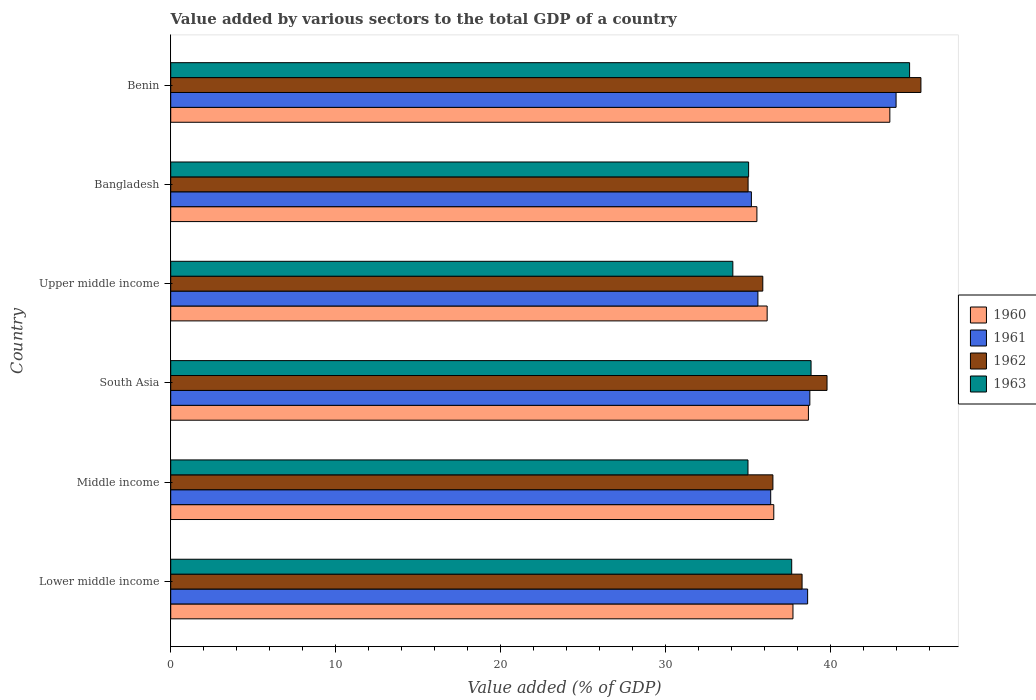How many groups of bars are there?
Keep it short and to the point. 6. How many bars are there on the 6th tick from the top?
Offer a terse response. 4. What is the value added by various sectors to the total GDP in 1960 in South Asia?
Ensure brevity in your answer.  38.68. Across all countries, what is the maximum value added by various sectors to the total GDP in 1963?
Make the answer very short. 44.81. Across all countries, what is the minimum value added by various sectors to the total GDP in 1960?
Give a very brief answer. 35.55. In which country was the value added by various sectors to the total GDP in 1961 maximum?
Make the answer very short. Benin. In which country was the value added by various sectors to the total GDP in 1960 minimum?
Provide a short and direct response. Bangladesh. What is the total value added by various sectors to the total GDP in 1963 in the graph?
Ensure brevity in your answer.  225.46. What is the difference between the value added by various sectors to the total GDP in 1961 in Benin and that in Lower middle income?
Make the answer very short. 5.36. What is the difference between the value added by various sectors to the total GDP in 1960 in Middle income and the value added by various sectors to the total GDP in 1963 in Benin?
Make the answer very short. -8.24. What is the average value added by various sectors to the total GDP in 1962 per country?
Offer a terse response. 38.51. What is the difference between the value added by various sectors to the total GDP in 1961 and value added by various sectors to the total GDP in 1963 in Benin?
Your answer should be very brief. -0.82. In how many countries, is the value added by various sectors to the total GDP in 1963 greater than 24 %?
Your answer should be very brief. 6. What is the ratio of the value added by various sectors to the total GDP in 1961 in Benin to that in Lower middle income?
Your answer should be compact. 1.14. What is the difference between the highest and the second highest value added by various sectors to the total GDP in 1962?
Your answer should be very brief. 5.69. What is the difference between the highest and the lowest value added by various sectors to the total GDP in 1962?
Offer a very short reply. 10.48. Is it the case that in every country, the sum of the value added by various sectors to the total GDP in 1960 and value added by various sectors to the total GDP in 1963 is greater than the sum of value added by various sectors to the total GDP in 1962 and value added by various sectors to the total GDP in 1961?
Ensure brevity in your answer.  No. What does the 3rd bar from the top in Benin represents?
Make the answer very short. 1961. Is it the case that in every country, the sum of the value added by various sectors to the total GDP in 1963 and value added by various sectors to the total GDP in 1960 is greater than the value added by various sectors to the total GDP in 1961?
Your answer should be very brief. Yes. How many bars are there?
Provide a short and direct response. 24. Are all the bars in the graph horizontal?
Ensure brevity in your answer.  Yes. How many countries are there in the graph?
Give a very brief answer. 6. Does the graph contain any zero values?
Your response must be concise. No. How are the legend labels stacked?
Give a very brief answer. Vertical. What is the title of the graph?
Make the answer very short. Value added by various sectors to the total GDP of a country. Does "2014" appear as one of the legend labels in the graph?
Your answer should be compact. No. What is the label or title of the X-axis?
Keep it short and to the point. Value added (% of GDP). What is the label or title of the Y-axis?
Your answer should be compact. Country. What is the Value added (% of GDP) of 1960 in Lower middle income?
Offer a very short reply. 37.74. What is the Value added (% of GDP) in 1961 in Lower middle income?
Your answer should be compact. 38.63. What is the Value added (% of GDP) in 1962 in Lower middle income?
Ensure brevity in your answer.  38.29. What is the Value added (% of GDP) in 1963 in Lower middle income?
Provide a short and direct response. 37.66. What is the Value added (% of GDP) in 1960 in Middle income?
Provide a succinct answer. 36.58. What is the Value added (% of GDP) in 1961 in Middle income?
Offer a very short reply. 36.39. What is the Value added (% of GDP) of 1962 in Middle income?
Keep it short and to the point. 36.52. What is the Value added (% of GDP) of 1963 in Middle income?
Your answer should be very brief. 35.01. What is the Value added (% of GDP) of 1960 in South Asia?
Your answer should be compact. 38.68. What is the Value added (% of GDP) of 1961 in South Asia?
Offer a very short reply. 38.76. What is the Value added (% of GDP) of 1962 in South Asia?
Your response must be concise. 39.81. What is the Value added (% of GDP) of 1963 in South Asia?
Keep it short and to the point. 38.84. What is the Value added (% of GDP) of 1960 in Upper middle income?
Your answer should be compact. 36.17. What is the Value added (% of GDP) of 1961 in Upper middle income?
Ensure brevity in your answer.  35.61. What is the Value added (% of GDP) of 1962 in Upper middle income?
Provide a short and direct response. 35.91. What is the Value added (% of GDP) of 1963 in Upper middle income?
Keep it short and to the point. 34.09. What is the Value added (% of GDP) in 1960 in Bangladesh?
Provide a short and direct response. 35.55. What is the Value added (% of GDP) of 1961 in Bangladesh?
Provide a short and direct response. 35.22. What is the Value added (% of GDP) in 1962 in Bangladesh?
Give a very brief answer. 35.02. What is the Value added (% of GDP) of 1963 in Bangladesh?
Provide a short and direct response. 35.05. What is the Value added (% of GDP) in 1960 in Benin?
Your answer should be compact. 43.62. What is the Value added (% of GDP) of 1961 in Benin?
Your answer should be compact. 43.99. What is the Value added (% of GDP) of 1962 in Benin?
Your answer should be compact. 45.5. What is the Value added (% of GDP) in 1963 in Benin?
Your answer should be very brief. 44.81. Across all countries, what is the maximum Value added (% of GDP) of 1960?
Your response must be concise. 43.62. Across all countries, what is the maximum Value added (% of GDP) in 1961?
Make the answer very short. 43.99. Across all countries, what is the maximum Value added (% of GDP) in 1962?
Ensure brevity in your answer.  45.5. Across all countries, what is the maximum Value added (% of GDP) of 1963?
Offer a very short reply. 44.81. Across all countries, what is the minimum Value added (% of GDP) of 1960?
Provide a succinct answer. 35.55. Across all countries, what is the minimum Value added (% of GDP) of 1961?
Offer a very short reply. 35.22. Across all countries, what is the minimum Value added (% of GDP) in 1962?
Make the answer very short. 35.02. Across all countries, what is the minimum Value added (% of GDP) of 1963?
Provide a short and direct response. 34.09. What is the total Value added (% of GDP) in 1960 in the graph?
Provide a short and direct response. 228.33. What is the total Value added (% of GDP) in 1961 in the graph?
Provide a short and direct response. 228.6. What is the total Value added (% of GDP) in 1962 in the graph?
Keep it short and to the point. 231.05. What is the total Value added (% of GDP) of 1963 in the graph?
Keep it short and to the point. 225.46. What is the difference between the Value added (% of GDP) of 1960 in Lower middle income and that in Middle income?
Give a very brief answer. 1.16. What is the difference between the Value added (% of GDP) in 1961 in Lower middle income and that in Middle income?
Keep it short and to the point. 2.24. What is the difference between the Value added (% of GDP) of 1962 in Lower middle income and that in Middle income?
Your answer should be very brief. 1.77. What is the difference between the Value added (% of GDP) of 1963 in Lower middle income and that in Middle income?
Provide a short and direct response. 2.65. What is the difference between the Value added (% of GDP) of 1960 in Lower middle income and that in South Asia?
Keep it short and to the point. -0.94. What is the difference between the Value added (% of GDP) in 1961 in Lower middle income and that in South Asia?
Offer a terse response. -0.13. What is the difference between the Value added (% of GDP) of 1962 in Lower middle income and that in South Asia?
Your answer should be very brief. -1.51. What is the difference between the Value added (% of GDP) in 1963 in Lower middle income and that in South Asia?
Give a very brief answer. -1.17. What is the difference between the Value added (% of GDP) of 1960 in Lower middle income and that in Upper middle income?
Ensure brevity in your answer.  1.57. What is the difference between the Value added (% of GDP) in 1961 in Lower middle income and that in Upper middle income?
Offer a very short reply. 3.02. What is the difference between the Value added (% of GDP) of 1962 in Lower middle income and that in Upper middle income?
Provide a succinct answer. 2.38. What is the difference between the Value added (% of GDP) in 1963 in Lower middle income and that in Upper middle income?
Your answer should be very brief. 3.57. What is the difference between the Value added (% of GDP) in 1960 in Lower middle income and that in Bangladesh?
Offer a very short reply. 2.19. What is the difference between the Value added (% of GDP) of 1961 in Lower middle income and that in Bangladesh?
Offer a very short reply. 3.41. What is the difference between the Value added (% of GDP) of 1962 in Lower middle income and that in Bangladesh?
Give a very brief answer. 3.27. What is the difference between the Value added (% of GDP) of 1963 in Lower middle income and that in Bangladesh?
Keep it short and to the point. 2.61. What is the difference between the Value added (% of GDP) in 1960 in Lower middle income and that in Benin?
Provide a short and direct response. -5.88. What is the difference between the Value added (% of GDP) in 1961 in Lower middle income and that in Benin?
Keep it short and to the point. -5.36. What is the difference between the Value added (% of GDP) in 1962 in Lower middle income and that in Benin?
Give a very brief answer. -7.21. What is the difference between the Value added (% of GDP) in 1963 in Lower middle income and that in Benin?
Your answer should be very brief. -7.15. What is the difference between the Value added (% of GDP) in 1960 in Middle income and that in South Asia?
Give a very brief answer. -2.1. What is the difference between the Value added (% of GDP) of 1961 in Middle income and that in South Asia?
Give a very brief answer. -2.37. What is the difference between the Value added (% of GDP) of 1962 in Middle income and that in South Asia?
Your response must be concise. -3.28. What is the difference between the Value added (% of GDP) in 1963 in Middle income and that in South Asia?
Offer a very short reply. -3.83. What is the difference between the Value added (% of GDP) of 1960 in Middle income and that in Upper middle income?
Provide a short and direct response. 0.4. What is the difference between the Value added (% of GDP) in 1961 in Middle income and that in Upper middle income?
Make the answer very short. 0.78. What is the difference between the Value added (% of GDP) of 1962 in Middle income and that in Upper middle income?
Your answer should be compact. 0.61. What is the difference between the Value added (% of GDP) of 1963 in Middle income and that in Upper middle income?
Provide a short and direct response. 0.92. What is the difference between the Value added (% of GDP) in 1960 in Middle income and that in Bangladesh?
Make the answer very short. 1.02. What is the difference between the Value added (% of GDP) in 1961 in Middle income and that in Bangladesh?
Your response must be concise. 1.17. What is the difference between the Value added (% of GDP) of 1962 in Middle income and that in Bangladesh?
Give a very brief answer. 1.5. What is the difference between the Value added (% of GDP) of 1963 in Middle income and that in Bangladesh?
Make the answer very short. -0.04. What is the difference between the Value added (% of GDP) of 1960 in Middle income and that in Benin?
Your answer should be very brief. -7.04. What is the difference between the Value added (% of GDP) in 1961 in Middle income and that in Benin?
Provide a short and direct response. -7.6. What is the difference between the Value added (% of GDP) of 1962 in Middle income and that in Benin?
Offer a very short reply. -8.98. What is the difference between the Value added (% of GDP) of 1963 in Middle income and that in Benin?
Give a very brief answer. -9.8. What is the difference between the Value added (% of GDP) of 1960 in South Asia and that in Upper middle income?
Your answer should be compact. 2.5. What is the difference between the Value added (% of GDP) in 1961 in South Asia and that in Upper middle income?
Your response must be concise. 3.15. What is the difference between the Value added (% of GDP) of 1962 in South Asia and that in Upper middle income?
Ensure brevity in your answer.  3.9. What is the difference between the Value added (% of GDP) of 1963 in South Asia and that in Upper middle income?
Your answer should be very brief. 4.74. What is the difference between the Value added (% of GDP) in 1960 in South Asia and that in Bangladesh?
Keep it short and to the point. 3.12. What is the difference between the Value added (% of GDP) in 1961 in South Asia and that in Bangladesh?
Offer a terse response. 3.54. What is the difference between the Value added (% of GDP) of 1962 in South Asia and that in Bangladesh?
Provide a succinct answer. 4.79. What is the difference between the Value added (% of GDP) in 1963 in South Asia and that in Bangladesh?
Provide a short and direct response. 3.79. What is the difference between the Value added (% of GDP) of 1960 in South Asia and that in Benin?
Keep it short and to the point. -4.94. What is the difference between the Value added (% of GDP) in 1961 in South Asia and that in Benin?
Keep it short and to the point. -5.23. What is the difference between the Value added (% of GDP) of 1962 in South Asia and that in Benin?
Offer a very short reply. -5.69. What is the difference between the Value added (% of GDP) in 1963 in South Asia and that in Benin?
Keep it short and to the point. -5.98. What is the difference between the Value added (% of GDP) in 1960 in Upper middle income and that in Bangladesh?
Your answer should be very brief. 0.62. What is the difference between the Value added (% of GDP) in 1961 in Upper middle income and that in Bangladesh?
Your response must be concise. 0.4. What is the difference between the Value added (% of GDP) of 1962 in Upper middle income and that in Bangladesh?
Provide a succinct answer. 0.89. What is the difference between the Value added (% of GDP) in 1963 in Upper middle income and that in Bangladesh?
Provide a short and direct response. -0.96. What is the difference between the Value added (% of GDP) of 1960 in Upper middle income and that in Benin?
Give a very brief answer. -7.44. What is the difference between the Value added (% of GDP) in 1961 in Upper middle income and that in Benin?
Offer a terse response. -8.38. What is the difference between the Value added (% of GDP) in 1962 in Upper middle income and that in Benin?
Your response must be concise. -9.59. What is the difference between the Value added (% of GDP) of 1963 in Upper middle income and that in Benin?
Your response must be concise. -10.72. What is the difference between the Value added (% of GDP) in 1960 in Bangladesh and that in Benin?
Offer a terse response. -8.06. What is the difference between the Value added (% of GDP) of 1961 in Bangladesh and that in Benin?
Offer a terse response. -8.78. What is the difference between the Value added (% of GDP) of 1962 in Bangladesh and that in Benin?
Your answer should be very brief. -10.48. What is the difference between the Value added (% of GDP) of 1963 in Bangladesh and that in Benin?
Make the answer very short. -9.76. What is the difference between the Value added (% of GDP) of 1960 in Lower middle income and the Value added (% of GDP) of 1961 in Middle income?
Your response must be concise. 1.35. What is the difference between the Value added (% of GDP) of 1960 in Lower middle income and the Value added (% of GDP) of 1962 in Middle income?
Provide a short and direct response. 1.22. What is the difference between the Value added (% of GDP) in 1960 in Lower middle income and the Value added (% of GDP) in 1963 in Middle income?
Offer a very short reply. 2.73. What is the difference between the Value added (% of GDP) in 1961 in Lower middle income and the Value added (% of GDP) in 1962 in Middle income?
Keep it short and to the point. 2.11. What is the difference between the Value added (% of GDP) of 1961 in Lower middle income and the Value added (% of GDP) of 1963 in Middle income?
Keep it short and to the point. 3.62. What is the difference between the Value added (% of GDP) of 1962 in Lower middle income and the Value added (% of GDP) of 1963 in Middle income?
Keep it short and to the point. 3.28. What is the difference between the Value added (% of GDP) in 1960 in Lower middle income and the Value added (% of GDP) in 1961 in South Asia?
Offer a terse response. -1.02. What is the difference between the Value added (% of GDP) in 1960 in Lower middle income and the Value added (% of GDP) in 1962 in South Asia?
Give a very brief answer. -2.07. What is the difference between the Value added (% of GDP) in 1960 in Lower middle income and the Value added (% of GDP) in 1963 in South Asia?
Your answer should be very brief. -1.1. What is the difference between the Value added (% of GDP) of 1961 in Lower middle income and the Value added (% of GDP) of 1962 in South Asia?
Your response must be concise. -1.18. What is the difference between the Value added (% of GDP) of 1961 in Lower middle income and the Value added (% of GDP) of 1963 in South Asia?
Provide a short and direct response. -0.21. What is the difference between the Value added (% of GDP) of 1962 in Lower middle income and the Value added (% of GDP) of 1963 in South Asia?
Give a very brief answer. -0.55. What is the difference between the Value added (% of GDP) in 1960 in Lower middle income and the Value added (% of GDP) in 1961 in Upper middle income?
Make the answer very short. 2.13. What is the difference between the Value added (% of GDP) of 1960 in Lower middle income and the Value added (% of GDP) of 1962 in Upper middle income?
Your answer should be compact. 1.83. What is the difference between the Value added (% of GDP) of 1960 in Lower middle income and the Value added (% of GDP) of 1963 in Upper middle income?
Your response must be concise. 3.65. What is the difference between the Value added (% of GDP) of 1961 in Lower middle income and the Value added (% of GDP) of 1962 in Upper middle income?
Provide a short and direct response. 2.72. What is the difference between the Value added (% of GDP) of 1961 in Lower middle income and the Value added (% of GDP) of 1963 in Upper middle income?
Your answer should be very brief. 4.54. What is the difference between the Value added (% of GDP) in 1962 in Lower middle income and the Value added (% of GDP) in 1963 in Upper middle income?
Offer a terse response. 4.2. What is the difference between the Value added (% of GDP) in 1960 in Lower middle income and the Value added (% of GDP) in 1961 in Bangladesh?
Make the answer very short. 2.52. What is the difference between the Value added (% of GDP) of 1960 in Lower middle income and the Value added (% of GDP) of 1962 in Bangladesh?
Your response must be concise. 2.72. What is the difference between the Value added (% of GDP) in 1960 in Lower middle income and the Value added (% of GDP) in 1963 in Bangladesh?
Your response must be concise. 2.69. What is the difference between the Value added (% of GDP) in 1961 in Lower middle income and the Value added (% of GDP) in 1962 in Bangladesh?
Make the answer very short. 3.61. What is the difference between the Value added (% of GDP) in 1961 in Lower middle income and the Value added (% of GDP) in 1963 in Bangladesh?
Provide a short and direct response. 3.58. What is the difference between the Value added (% of GDP) of 1962 in Lower middle income and the Value added (% of GDP) of 1963 in Bangladesh?
Your response must be concise. 3.24. What is the difference between the Value added (% of GDP) in 1960 in Lower middle income and the Value added (% of GDP) in 1961 in Benin?
Make the answer very short. -6.25. What is the difference between the Value added (% of GDP) in 1960 in Lower middle income and the Value added (% of GDP) in 1962 in Benin?
Ensure brevity in your answer.  -7.76. What is the difference between the Value added (% of GDP) of 1960 in Lower middle income and the Value added (% of GDP) of 1963 in Benin?
Your answer should be compact. -7.07. What is the difference between the Value added (% of GDP) in 1961 in Lower middle income and the Value added (% of GDP) in 1962 in Benin?
Provide a short and direct response. -6.87. What is the difference between the Value added (% of GDP) of 1961 in Lower middle income and the Value added (% of GDP) of 1963 in Benin?
Your answer should be very brief. -6.18. What is the difference between the Value added (% of GDP) in 1962 in Lower middle income and the Value added (% of GDP) in 1963 in Benin?
Ensure brevity in your answer.  -6.52. What is the difference between the Value added (% of GDP) in 1960 in Middle income and the Value added (% of GDP) in 1961 in South Asia?
Your answer should be compact. -2.19. What is the difference between the Value added (% of GDP) of 1960 in Middle income and the Value added (% of GDP) of 1962 in South Asia?
Provide a succinct answer. -3.23. What is the difference between the Value added (% of GDP) of 1960 in Middle income and the Value added (% of GDP) of 1963 in South Asia?
Ensure brevity in your answer.  -2.26. What is the difference between the Value added (% of GDP) of 1961 in Middle income and the Value added (% of GDP) of 1962 in South Asia?
Give a very brief answer. -3.42. What is the difference between the Value added (% of GDP) in 1961 in Middle income and the Value added (% of GDP) in 1963 in South Asia?
Provide a short and direct response. -2.45. What is the difference between the Value added (% of GDP) in 1962 in Middle income and the Value added (% of GDP) in 1963 in South Asia?
Your answer should be compact. -2.31. What is the difference between the Value added (% of GDP) in 1960 in Middle income and the Value added (% of GDP) in 1961 in Upper middle income?
Your answer should be very brief. 0.96. What is the difference between the Value added (% of GDP) of 1960 in Middle income and the Value added (% of GDP) of 1962 in Upper middle income?
Your answer should be very brief. 0.67. What is the difference between the Value added (% of GDP) in 1960 in Middle income and the Value added (% of GDP) in 1963 in Upper middle income?
Provide a succinct answer. 2.48. What is the difference between the Value added (% of GDP) of 1961 in Middle income and the Value added (% of GDP) of 1962 in Upper middle income?
Your answer should be very brief. 0.48. What is the difference between the Value added (% of GDP) in 1961 in Middle income and the Value added (% of GDP) in 1963 in Upper middle income?
Give a very brief answer. 2.3. What is the difference between the Value added (% of GDP) of 1962 in Middle income and the Value added (% of GDP) of 1963 in Upper middle income?
Offer a terse response. 2.43. What is the difference between the Value added (% of GDP) of 1960 in Middle income and the Value added (% of GDP) of 1961 in Bangladesh?
Your response must be concise. 1.36. What is the difference between the Value added (% of GDP) of 1960 in Middle income and the Value added (% of GDP) of 1962 in Bangladesh?
Ensure brevity in your answer.  1.56. What is the difference between the Value added (% of GDP) of 1960 in Middle income and the Value added (% of GDP) of 1963 in Bangladesh?
Offer a very short reply. 1.53. What is the difference between the Value added (% of GDP) in 1961 in Middle income and the Value added (% of GDP) in 1962 in Bangladesh?
Offer a terse response. 1.37. What is the difference between the Value added (% of GDP) of 1961 in Middle income and the Value added (% of GDP) of 1963 in Bangladesh?
Offer a very short reply. 1.34. What is the difference between the Value added (% of GDP) of 1962 in Middle income and the Value added (% of GDP) of 1963 in Bangladesh?
Provide a short and direct response. 1.47. What is the difference between the Value added (% of GDP) in 1960 in Middle income and the Value added (% of GDP) in 1961 in Benin?
Offer a very short reply. -7.42. What is the difference between the Value added (% of GDP) of 1960 in Middle income and the Value added (% of GDP) of 1962 in Benin?
Provide a short and direct response. -8.92. What is the difference between the Value added (% of GDP) of 1960 in Middle income and the Value added (% of GDP) of 1963 in Benin?
Give a very brief answer. -8.24. What is the difference between the Value added (% of GDP) in 1961 in Middle income and the Value added (% of GDP) in 1962 in Benin?
Your response must be concise. -9.11. What is the difference between the Value added (% of GDP) of 1961 in Middle income and the Value added (% of GDP) of 1963 in Benin?
Provide a succinct answer. -8.42. What is the difference between the Value added (% of GDP) of 1962 in Middle income and the Value added (% of GDP) of 1963 in Benin?
Your response must be concise. -8.29. What is the difference between the Value added (% of GDP) in 1960 in South Asia and the Value added (% of GDP) in 1961 in Upper middle income?
Provide a succinct answer. 3.06. What is the difference between the Value added (% of GDP) of 1960 in South Asia and the Value added (% of GDP) of 1962 in Upper middle income?
Offer a very short reply. 2.77. What is the difference between the Value added (% of GDP) of 1960 in South Asia and the Value added (% of GDP) of 1963 in Upper middle income?
Your response must be concise. 4.58. What is the difference between the Value added (% of GDP) of 1961 in South Asia and the Value added (% of GDP) of 1962 in Upper middle income?
Your answer should be compact. 2.85. What is the difference between the Value added (% of GDP) of 1961 in South Asia and the Value added (% of GDP) of 1963 in Upper middle income?
Your answer should be very brief. 4.67. What is the difference between the Value added (% of GDP) in 1962 in South Asia and the Value added (% of GDP) in 1963 in Upper middle income?
Your response must be concise. 5.71. What is the difference between the Value added (% of GDP) in 1960 in South Asia and the Value added (% of GDP) in 1961 in Bangladesh?
Ensure brevity in your answer.  3.46. What is the difference between the Value added (% of GDP) of 1960 in South Asia and the Value added (% of GDP) of 1962 in Bangladesh?
Offer a very short reply. 3.66. What is the difference between the Value added (% of GDP) of 1960 in South Asia and the Value added (% of GDP) of 1963 in Bangladesh?
Your answer should be compact. 3.63. What is the difference between the Value added (% of GDP) in 1961 in South Asia and the Value added (% of GDP) in 1962 in Bangladesh?
Offer a terse response. 3.74. What is the difference between the Value added (% of GDP) in 1961 in South Asia and the Value added (% of GDP) in 1963 in Bangladesh?
Offer a terse response. 3.71. What is the difference between the Value added (% of GDP) of 1962 in South Asia and the Value added (% of GDP) of 1963 in Bangladesh?
Provide a succinct answer. 4.76. What is the difference between the Value added (% of GDP) in 1960 in South Asia and the Value added (% of GDP) in 1961 in Benin?
Your response must be concise. -5.32. What is the difference between the Value added (% of GDP) of 1960 in South Asia and the Value added (% of GDP) of 1962 in Benin?
Offer a very short reply. -6.82. What is the difference between the Value added (% of GDP) in 1960 in South Asia and the Value added (% of GDP) in 1963 in Benin?
Give a very brief answer. -6.14. What is the difference between the Value added (% of GDP) of 1961 in South Asia and the Value added (% of GDP) of 1962 in Benin?
Your answer should be compact. -6.74. What is the difference between the Value added (% of GDP) in 1961 in South Asia and the Value added (% of GDP) in 1963 in Benin?
Make the answer very short. -6.05. What is the difference between the Value added (% of GDP) in 1962 in South Asia and the Value added (% of GDP) in 1963 in Benin?
Offer a very short reply. -5.01. What is the difference between the Value added (% of GDP) of 1960 in Upper middle income and the Value added (% of GDP) of 1961 in Bangladesh?
Keep it short and to the point. 0.96. What is the difference between the Value added (% of GDP) in 1960 in Upper middle income and the Value added (% of GDP) in 1962 in Bangladesh?
Ensure brevity in your answer.  1.16. What is the difference between the Value added (% of GDP) of 1960 in Upper middle income and the Value added (% of GDP) of 1963 in Bangladesh?
Offer a very short reply. 1.12. What is the difference between the Value added (% of GDP) of 1961 in Upper middle income and the Value added (% of GDP) of 1962 in Bangladesh?
Your answer should be very brief. 0.6. What is the difference between the Value added (% of GDP) of 1961 in Upper middle income and the Value added (% of GDP) of 1963 in Bangladesh?
Keep it short and to the point. 0.56. What is the difference between the Value added (% of GDP) of 1962 in Upper middle income and the Value added (% of GDP) of 1963 in Bangladesh?
Offer a very short reply. 0.86. What is the difference between the Value added (% of GDP) in 1960 in Upper middle income and the Value added (% of GDP) in 1961 in Benin?
Offer a very short reply. -7.82. What is the difference between the Value added (% of GDP) of 1960 in Upper middle income and the Value added (% of GDP) of 1962 in Benin?
Give a very brief answer. -9.33. What is the difference between the Value added (% of GDP) in 1960 in Upper middle income and the Value added (% of GDP) in 1963 in Benin?
Offer a very short reply. -8.64. What is the difference between the Value added (% of GDP) of 1961 in Upper middle income and the Value added (% of GDP) of 1962 in Benin?
Your answer should be very brief. -9.89. What is the difference between the Value added (% of GDP) in 1961 in Upper middle income and the Value added (% of GDP) in 1963 in Benin?
Provide a short and direct response. -9.2. What is the difference between the Value added (% of GDP) in 1962 in Upper middle income and the Value added (% of GDP) in 1963 in Benin?
Make the answer very short. -8.9. What is the difference between the Value added (% of GDP) of 1960 in Bangladesh and the Value added (% of GDP) of 1961 in Benin?
Your answer should be compact. -8.44. What is the difference between the Value added (% of GDP) of 1960 in Bangladesh and the Value added (% of GDP) of 1962 in Benin?
Offer a terse response. -9.95. What is the difference between the Value added (% of GDP) in 1960 in Bangladesh and the Value added (% of GDP) in 1963 in Benin?
Your answer should be very brief. -9.26. What is the difference between the Value added (% of GDP) in 1961 in Bangladesh and the Value added (% of GDP) in 1962 in Benin?
Offer a terse response. -10.28. What is the difference between the Value added (% of GDP) in 1961 in Bangladesh and the Value added (% of GDP) in 1963 in Benin?
Provide a succinct answer. -9.59. What is the difference between the Value added (% of GDP) of 1962 in Bangladesh and the Value added (% of GDP) of 1963 in Benin?
Provide a succinct answer. -9.79. What is the average Value added (% of GDP) in 1960 per country?
Your answer should be compact. 38.06. What is the average Value added (% of GDP) of 1961 per country?
Your response must be concise. 38.1. What is the average Value added (% of GDP) in 1962 per country?
Your response must be concise. 38.51. What is the average Value added (% of GDP) of 1963 per country?
Give a very brief answer. 37.58. What is the difference between the Value added (% of GDP) in 1960 and Value added (% of GDP) in 1961 in Lower middle income?
Give a very brief answer. -0.89. What is the difference between the Value added (% of GDP) of 1960 and Value added (% of GDP) of 1962 in Lower middle income?
Your response must be concise. -0.55. What is the difference between the Value added (% of GDP) of 1960 and Value added (% of GDP) of 1963 in Lower middle income?
Offer a terse response. 0.08. What is the difference between the Value added (% of GDP) of 1961 and Value added (% of GDP) of 1962 in Lower middle income?
Provide a succinct answer. 0.34. What is the difference between the Value added (% of GDP) in 1961 and Value added (% of GDP) in 1963 in Lower middle income?
Keep it short and to the point. 0.97. What is the difference between the Value added (% of GDP) in 1962 and Value added (% of GDP) in 1963 in Lower middle income?
Provide a succinct answer. 0.63. What is the difference between the Value added (% of GDP) in 1960 and Value added (% of GDP) in 1961 in Middle income?
Provide a succinct answer. 0.19. What is the difference between the Value added (% of GDP) in 1960 and Value added (% of GDP) in 1962 in Middle income?
Keep it short and to the point. 0.05. What is the difference between the Value added (% of GDP) in 1960 and Value added (% of GDP) in 1963 in Middle income?
Give a very brief answer. 1.56. What is the difference between the Value added (% of GDP) of 1961 and Value added (% of GDP) of 1962 in Middle income?
Make the answer very short. -0.13. What is the difference between the Value added (% of GDP) in 1961 and Value added (% of GDP) in 1963 in Middle income?
Offer a terse response. 1.38. What is the difference between the Value added (% of GDP) of 1962 and Value added (% of GDP) of 1963 in Middle income?
Provide a short and direct response. 1.51. What is the difference between the Value added (% of GDP) in 1960 and Value added (% of GDP) in 1961 in South Asia?
Make the answer very short. -0.09. What is the difference between the Value added (% of GDP) of 1960 and Value added (% of GDP) of 1962 in South Asia?
Your response must be concise. -1.13. What is the difference between the Value added (% of GDP) of 1960 and Value added (% of GDP) of 1963 in South Asia?
Your response must be concise. -0.16. What is the difference between the Value added (% of GDP) in 1961 and Value added (% of GDP) in 1962 in South Asia?
Keep it short and to the point. -1.04. What is the difference between the Value added (% of GDP) in 1961 and Value added (% of GDP) in 1963 in South Asia?
Give a very brief answer. -0.07. What is the difference between the Value added (% of GDP) in 1962 and Value added (% of GDP) in 1963 in South Asia?
Ensure brevity in your answer.  0.97. What is the difference between the Value added (% of GDP) in 1960 and Value added (% of GDP) in 1961 in Upper middle income?
Offer a terse response. 0.56. What is the difference between the Value added (% of GDP) in 1960 and Value added (% of GDP) in 1962 in Upper middle income?
Your answer should be compact. 0.26. What is the difference between the Value added (% of GDP) in 1960 and Value added (% of GDP) in 1963 in Upper middle income?
Provide a short and direct response. 2.08. What is the difference between the Value added (% of GDP) in 1961 and Value added (% of GDP) in 1962 in Upper middle income?
Make the answer very short. -0.3. What is the difference between the Value added (% of GDP) of 1961 and Value added (% of GDP) of 1963 in Upper middle income?
Offer a terse response. 1.52. What is the difference between the Value added (% of GDP) of 1962 and Value added (% of GDP) of 1963 in Upper middle income?
Ensure brevity in your answer.  1.82. What is the difference between the Value added (% of GDP) of 1960 and Value added (% of GDP) of 1961 in Bangladesh?
Give a very brief answer. 0.33. What is the difference between the Value added (% of GDP) of 1960 and Value added (% of GDP) of 1962 in Bangladesh?
Provide a succinct answer. 0.53. What is the difference between the Value added (% of GDP) of 1960 and Value added (% of GDP) of 1963 in Bangladesh?
Your answer should be very brief. 0.5. What is the difference between the Value added (% of GDP) in 1961 and Value added (% of GDP) in 1962 in Bangladesh?
Give a very brief answer. 0.2. What is the difference between the Value added (% of GDP) in 1961 and Value added (% of GDP) in 1963 in Bangladesh?
Provide a short and direct response. 0.17. What is the difference between the Value added (% of GDP) of 1962 and Value added (% of GDP) of 1963 in Bangladesh?
Provide a short and direct response. -0.03. What is the difference between the Value added (% of GDP) in 1960 and Value added (% of GDP) in 1961 in Benin?
Give a very brief answer. -0.38. What is the difference between the Value added (% of GDP) in 1960 and Value added (% of GDP) in 1962 in Benin?
Your answer should be compact. -1.88. What is the difference between the Value added (% of GDP) in 1960 and Value added (% of GDP) in 1963 in Benin?
Offer a terse response. -1.2. What is the difference between the Value added (% of GDP) of 1961 and Value added (% of GDP) of 1962 in Benin?
Provide a succinct answer. -1.51. What is the difference between the Value added (% of GDP) of 1961 and Value added (% of GDP) of 1963 in Benin?
Your answer should be very brief. -0.82. What is the difference between the Value added (% of GDP) of 1962 and Value added (% of GDP) of 1963 in Benin?
Offer a terse response. 0.69. What is the ratio of the Value added (% of GDP) in 1960 in Lower middle income to that in Middle income?
Ensure brevity in your answer.  1.03. What is the ratio of the Value added (% of GDP) in 1961 in Lower middle income to that in Middle income?
Offer a terse response. 1.06. What is the ratio of the Value added (% of GDP) in 1962 in Lower middle income to that in Middle income?
Offer a terse response. 1.05. What is the ratio of the Value added (% of GDP) in 1963 in Lower middle income to that in Middle income?
Give a very brief answer. 1.08. What is the ratio of the Value added (% of GDP) in 1960 in Lower middle income to that in South Asia?
Ensure brevity in your answer.  0.98. What is the ratio of the Value added (% of GDP) in 1963 in Lower middle income to that in South Asia?
Your response must be concise. 0.97. What is the ratio of the Value added (% of GDP) of 1960 in Lower middle income to that in Upper middle income?
Offer a terse response. 1.04. What is the ratio of the Value added (% of GDP) of 1961 in Lower middle income to that in Upper middle income?
Ensure brevity in your answer.  1.08. What is the ratio of the Value added (% of GDP) of 1962 in Lower middle income to that in Upper middle income?
Make the answer very short. 1.07. What is the ratio of the Value added (% of GDP) in 1963 in Lower middle income to that in Upper middle income?
Offer a terse response. 1.1. What is the ratio of the Value added (% of GDP) of 1960 in Lower middle income to that in Bangladesh?
Your answer should be very brief. 1.06. What is the ratio of the Value added (% of GDP) of 1961 in Lower middle income to that in Bangladesh?
Ensure brevity in your answer.  1.1. What is the ratio of the Value added (% of GDP) of 1962 in Lower middle income to that in Bangladesh?
Your response must be concise. 1.09. What is the ratio of the Value added (% of GDP) in 1963 in Lower middle income to that in Bangladesh?
Your response must be concise. 1.07. What is the ratio of the Value added (% of GDP) of 1960 in Lower middle income to that in Benin?
Your answer should be compact. 0.87. What is the ratio of the Value added (% of GDP) of 1961 in Lower middle income to that in Benin?
Make the answer very short. 0.88. What is the ratio of the Value added (% of GDP) in 1962 in Lower middle income to that in Benin?
Provide a short and direct response. 0.84. What is the ratio of the Value added (% of GDP) of 1963 in Lower middle income to that in Benin?
Provide a succinct answer. 0.84. What is the ratio of the Value added (% of GDP) in 1960 in Middle income to that in South Asia?
Keep it short and to the point. 0.95. What is the ratio of the Value added (% of GDP) in 1961 in Middle income to that in South Asia?
Provide a short and direct response. 0.94. What is the ratio of the Value added (% of GDP) in 1962 in Middle income to that in South Asia?
Your answer should be compact. 0.92. What is the ratio of the Value added (% of GDP) of 1963 in Middle income to that in South Asia?
Give a very brief answer. 0.9. What is the ratio of the Value added (% of GDP) of 1960 in Middle income to that in Upper middle income?
Provide a short and direct response. 1.01. What is the ratio of the Value added (% of GDP) in 1961 in Middle income to that in Upper middle income?
Your response must be concise. 1.02. What is the ratio of the Value added (% of GDP) in 1962 in Middle income to that in Upper middle income?
Offer a very short reply. 1.02. What is the ratio of the Value added (% of GDP) of 1963 in Middle income to that in Upper middle income?
Your answer should be very brief. 1.03. What is the ratio of the Value added (% of GDP) of 1960 in Middle income to that in Bangladesh?
Make the answer very short. 1.03. What is the ratio of the Value added (% of GDP) in 1961 in Middle income to that in Bangladesh?
Offer a very short reply. 1.03. What is the ratio of the Value added (% of GDP) of 1962 in Middle income to that in Bangladesh?
Provide a succinct answer. 1.04. What is the ratio of the Value added (% of GDP) in 1963 in Middle income to that in Bangladesh?
Your response must be concise. 1. What is the ratio of the Value added (% of GDP) of 1960 in Middle income to that in Benin?
Your answer should be very brief. 0.84. What is the ratio of the Value added (% of GDP) in 1961 in Middle income to that in Benin?
Offer a very short reply. 0.83. What is the ratio of the Value added (% of GDP) in 1962 in Middle income to that in Benin?
Give a very brief answer. 0.8. What is the ratio of the Value added (% of GDP) of 1963 in Middle income to that in Benin?
Offer a terse response. 0.78. What is the ratio of the Value added (% of GDP) of 1960 in South Asia to that in Upper middle income?
Provide a short and direct response. 1.07. What is the ratio of the Value added (% of GDP) in 1961 in South Asia to that in Upper middle income?
Your answer should be compact. 1.09. What is the ratio of the Value added (% of GDP) in 1962 in South Asia to that in Upper middle income?
Provide a short and direct response. 1.11. What is the ratio of the Value added (% of GDP) of 1963 in South Asia to that in Upper middle income?
Keep it short and to the point. 1.14. What is the ratio of the Value added (% of GDP) of 1960 in South Asia to that in Bangladesh?
Make the answer very short. 1.09. What is the ratio of the Value added (% of GDP) of 1961 in South Asia to that in Bangladesh?
Your response must be concise. 1.1. What is the ratio of the Value added (% of GDP) of 1962 in South Asia to that in Bangladesh?
Offer a very short reply. 1.14. What is the ratio of the Value added (% of GDP) in 1963 in South Asia to that in Bangladesh?
Give a very brief answer. 1.11. What is the ratio of the Value added (% of GDP) in 1960 in South Asia to that in Benin?
Provide a succinct answer. 0.89. What is the ratio of the Value added (% of GDP) of 1961 in South Asia to that in Benin?
Make the answer very short. 0.88. What is the ratio of the Value added (% of GDP) of 1962 in South Asia to that in Benin?
Provide a succinct answer. 0.87. What is the ratio of the Value added (% of GDP) in 1963 in South Asia to that in Benin?
Offer a very short reply. 0.87. What is the ratio of the Value added (% of GDP) of 1960 in Upper middle income to that in Bangladesh?
Your answer should be very brief. 1.02. What is the ratio of the Value added (% of GDP) of 1961 in Upper middle income to that in Bangladesh?
Offer a very short reply. 1.01. What is the ratio of the Value added (% of GDP) in 1962 in Upper middle income to that in Bangladesh?
Your response must be concise. 1.03. What is the ratio of the Value added (% of GDP) of 1963 in Upper middle income to that in Bangladesh?
Your answer should be compact. 0.97. What is the ratio of the Value added (% of GDP) in 1960 in Upper middle income to that in Benin?
Provide a short and direct response. 0.83. What is the ratio of the Value added (% of GDP) in 1961 in Upper middle income to that in Benin?
Keep it short and to the point. 0.81. What is the ratio of the Value added (% of GDP) of 1962 in Upper middle income to that in Benin?
Your answer should be compact. 0.79. What is the ratio of the Value added (% of GDP) in 1963 in Upper middle income to that in Benin?
Ensure brevity in your answer.  0.76. What is the ratio of the Value added (% of GDP) of 1960 in Bangladesh to that in Benin?
Your answer should be very brief. 0.82. What is the ratio of the Value added (% of GDP) in 1961 in Bangladesh to that in Benin?
Your answer should be very brief. 0.8. What is the ratio of the Value added (% of GDP) in 1962 in Bangladesh to that in Benin?
Your answer should be very brief. 0.77. What is the ratio of the Value added (% of GDP) in 1963 in Bangladesh to that in Benin?
Give a very brief answer. 0.78. What is the difference between the highest and the second highest Value added (% of GDP) of 1960?
Ensure brevity in your answer.  4.94. What is the difference between the highest and the second highest Value added (% of GDP) of 1961?
Ensure brevity in your answer.  5.23. What is the difference between the highest and the second highest Value added (% of GDP) of 1962?
Your answer should be compact. 5.69. What is the difference between the highest and the second highest Value added (% of GDP) in 1963?
Your answer should be very brief. 5.98. What is the difference between the highest and the lowest Value added (% of GDP) of 1960?
Provide a succinct answer. 8.06. What is the difference between the highest and the lowest Value added (% of GDP) in 1961?
Provide a short and direct response. 8.78. What is the difference between the highest and the lowest Value added (% of GDP) of 1962?
Offer a terse response. 10.48. What is the difference between the highest and the lowest Value added (% of GDP) of 1963?
Keep it short and to the point. 10.72. 